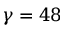<formula> <loc_0><loc_0><loc_500><loc_500>\gamma = 4 8</formula> 